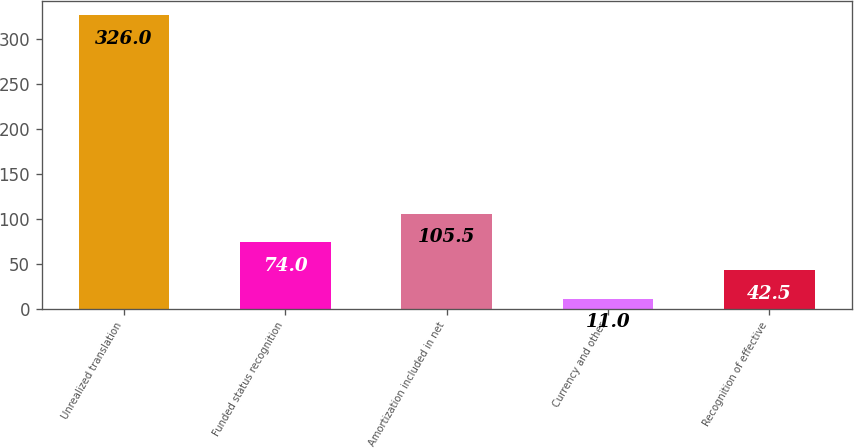Convert chart to OTSL. <chart><loc_0><loc_0><loc_500><loc_500><bar_chart><fcel>Unrealized translation<fcel>Funded status recognition<fcel>Amortization included in net<fcel>Currency and other<fcel>Recognition of effective<nl><fcel>326<fcel>74<fcel>105.5<fcel>11<fcel>42.5<nl></chart> 